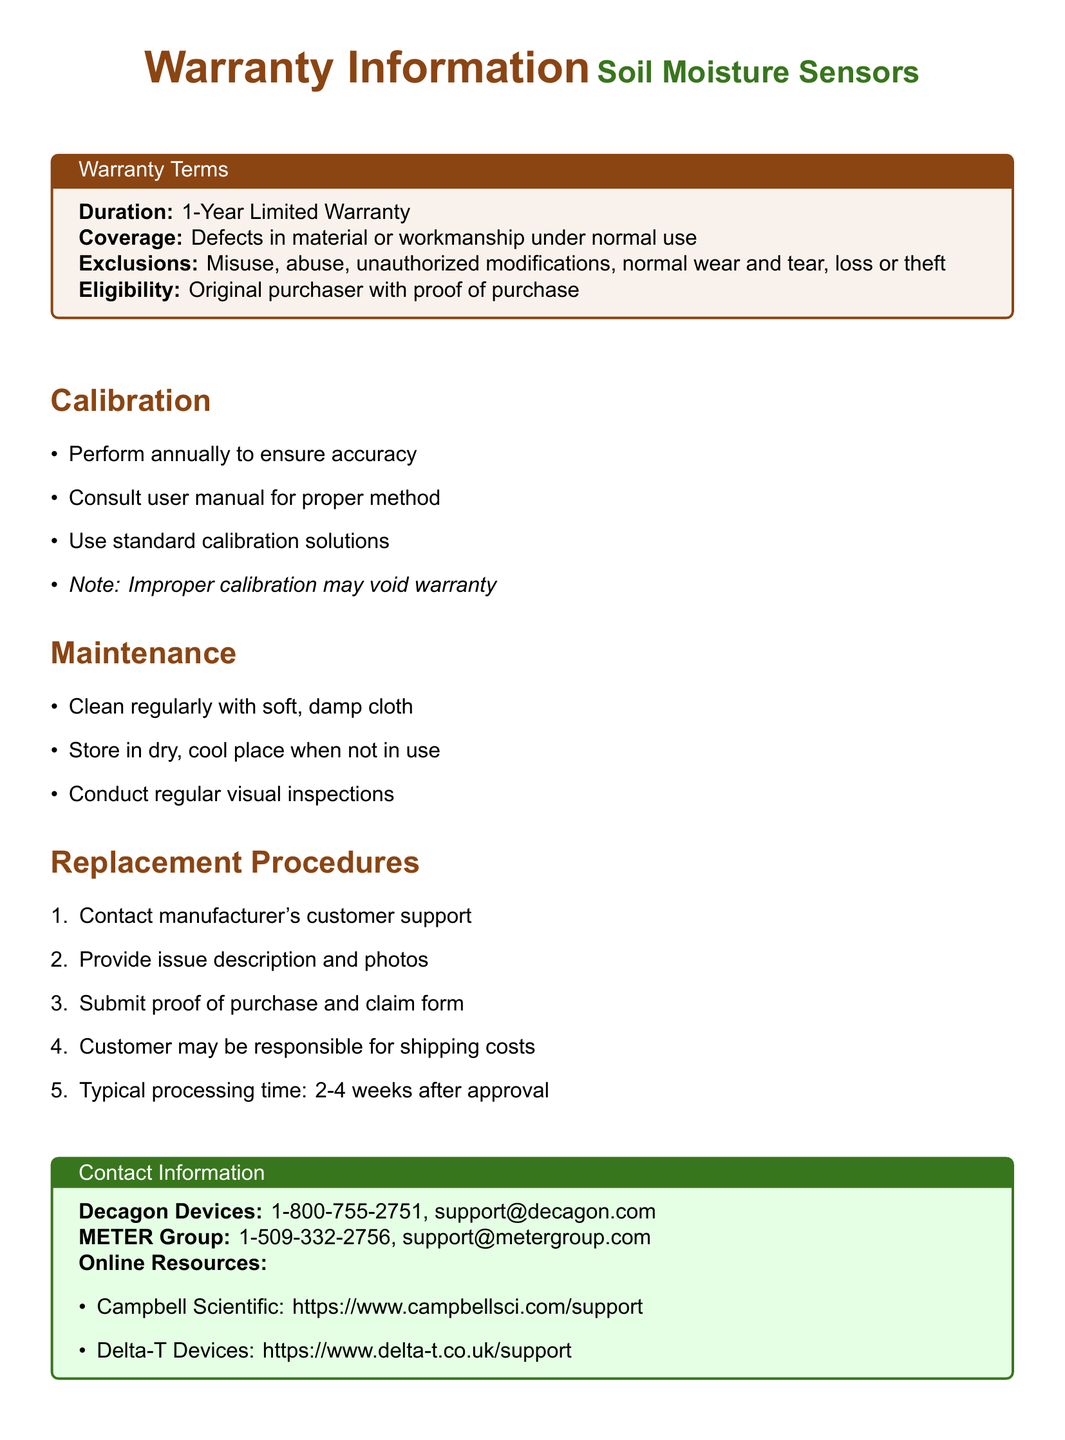What is the duration of the warranty? The warranty duration is explicitly stated in the document under the warranty terms.
Answer: 1-Year Limited Warranty What are the exclusions of the warranty? The document lists specific circumstances that are excluded from warranty coverage.
Answer: Misuse, abuse, unauthorized modifications, normal wear and tear, loss or theft What should be used for calibration? The calibration section specifies the necessary materials for proper calibration of soil moisture sensors.
Answer: Standard calibration solutions How often should calibration be performed? The calibration section indicates how frequently the calibration must be conducted to ensure accuracy.
Answer: Annually What is the typical processing time for replacement after approval? The replacement procedures provide information on the time frame for processing claims.
Answer: 2-4 weeks Who should be contacted for support regarding warranty issues? The contact information section lists the customer support contacts for assistance.
Answer: Decagon Devices: 1-800-755-2751 What must the customer provide for replacement claims? The replacement procedures outline the necessary documentation and details needed to process a claim.
Answer: Proof of purchase and claim form What is the storage condition recommended when not in use? The maintenance section details the proper storage conditions for the sensors.
Answer: Dry, cool place What may void the warranty? The calibration section mentions specific actions that could result in the warranty being voided.
Answer: Improper calibration 